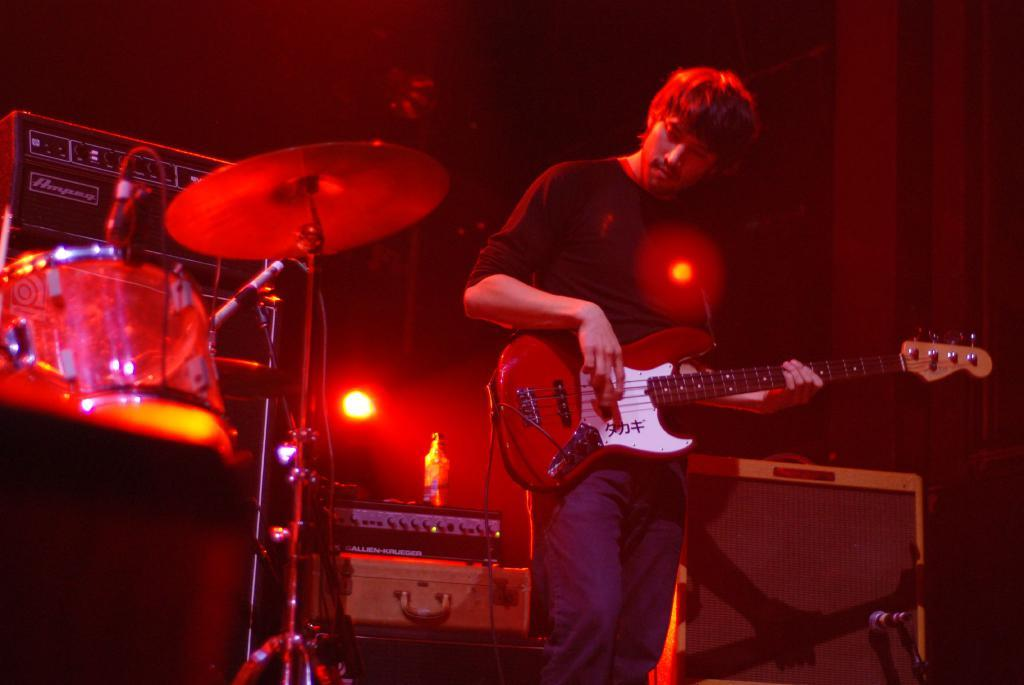What is the person in the image doing? There is a person playing a guitar in the image. What else can be seen in the image related to music? There are other musical instruments in the image. Can you describe an object in the right corner of the image? A microphone is present in the right corner of the image. What type of lettuce is being used as a prop in the image? There is no lettuce present in the image. How many chickens are visible in the image? There are no chickens visible in the image. 